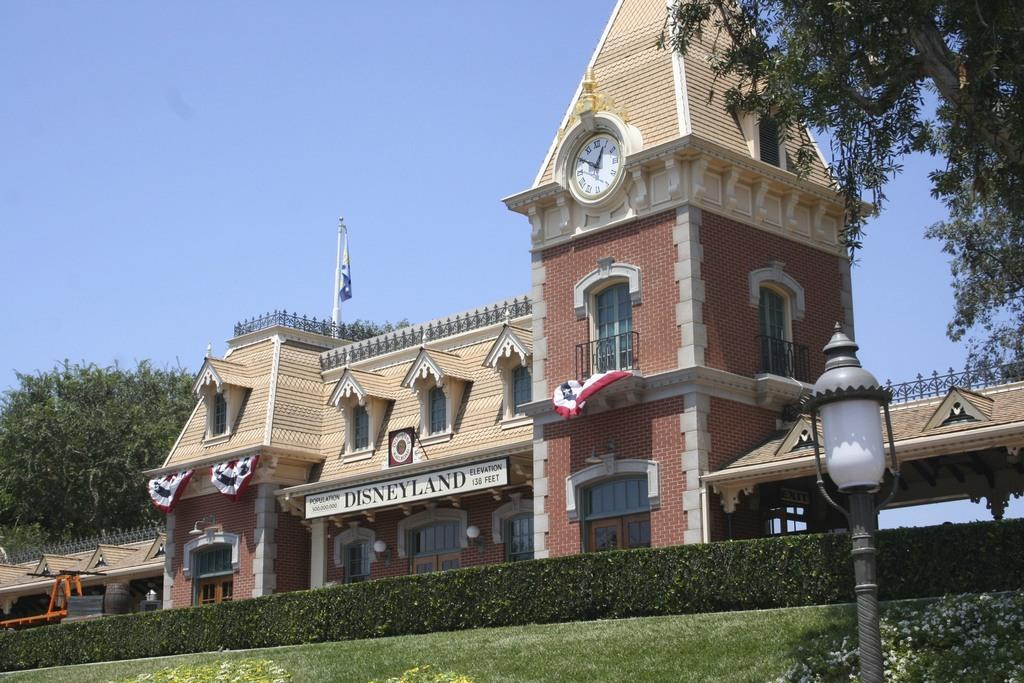<image>
Share a concise interpretation of the image provided. A building with a banner saying Disneyland has a clock tower. 